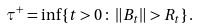<formula> <loc_0><loc_0><loc_500><loc_500>\tau ^ { + } = \inf \left \{ t > 0 \, \colon \, \| B _ { t } \| > R _ { t } \right \} .</formula> 